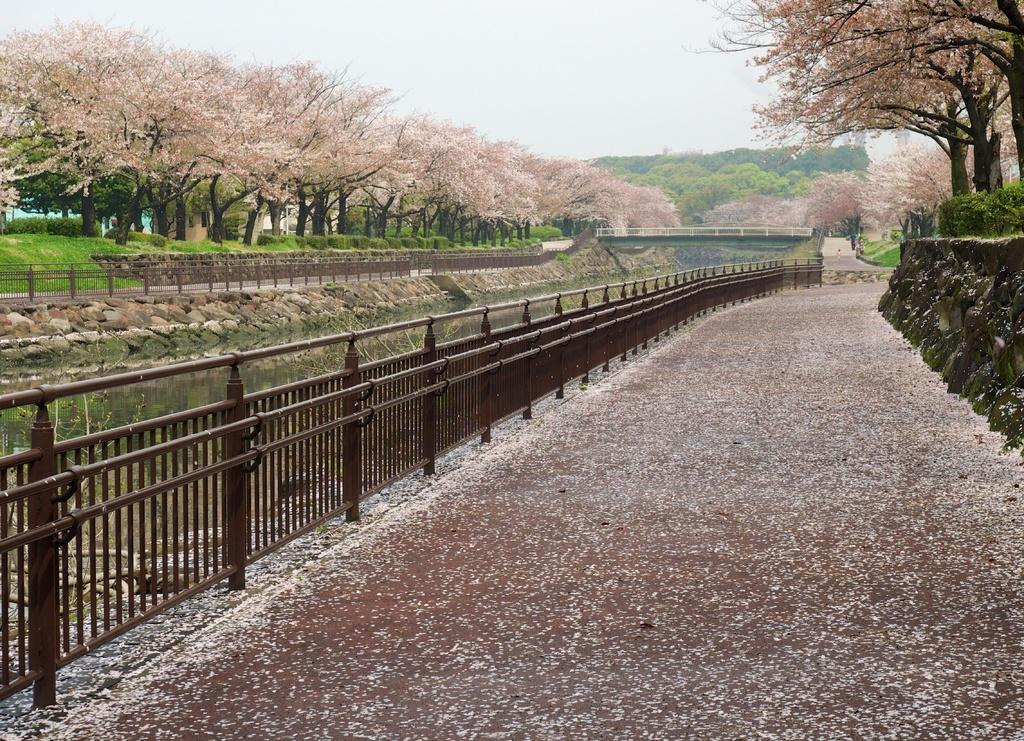What type of surface can be seen in the image? There is ground visible in the image. What type of structure is present in the image? There is a bridge in the image. What material is used for the railing in the image? The railing in the image is made of metal. What natural element is present in the image? There is water in the image. What type of vegetation can be seen in the image? There are trees in the image, with colors green, black, and brown. What can be seen in the background of the image? The sky is visible in the background of the image. What type of soup is being served in the image? There is no soup present in the image. Can you describe the veins in the trees in the image? There are no veins visible in the trees in the image, as trees do not have veins like animals do. 